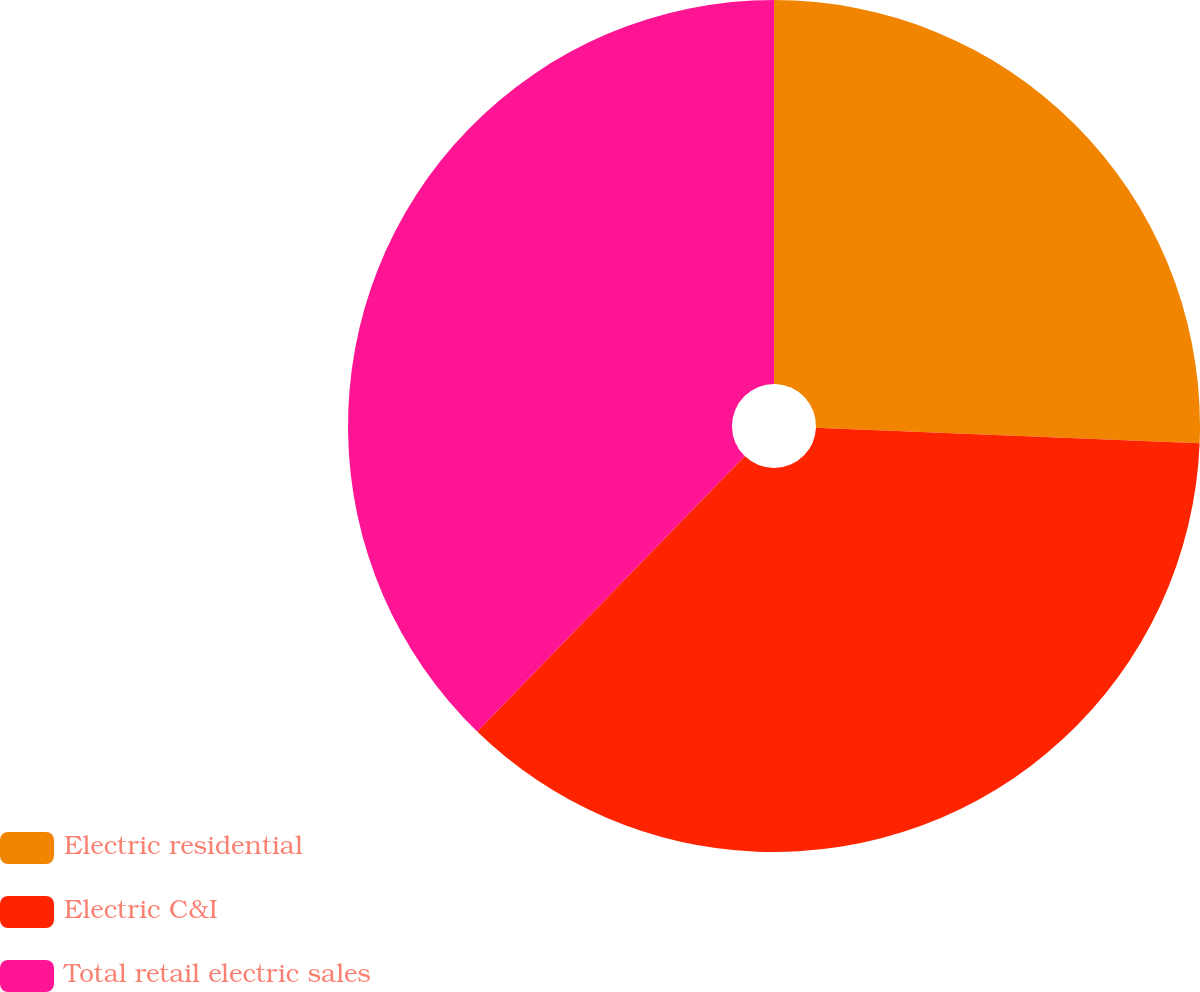<chart> <loc_0><loc_0><loc_500><loc_500><pie_chart><fcel>Electric residential<fcel>Electric C&I<fcel>Total retail electric sales<nl><fcel>25.64%<fcel>36.63%<fcel>37.73%<nl></chart> 